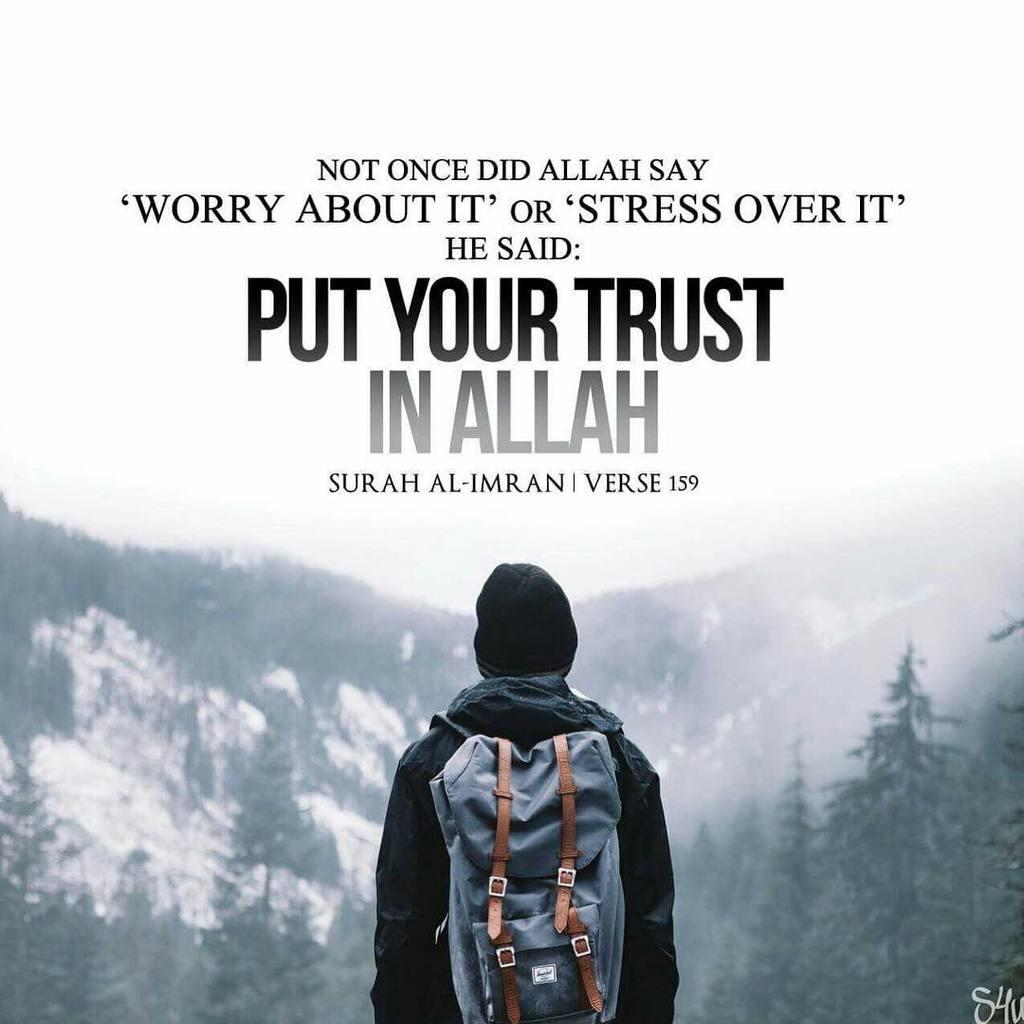Who is present in the image? There is a man in the image. What is the man wearing? The man is wearing a black shirt. What is the man carrying? The man is carrying a backpack. What can be seen in the background of the image? There are trees, snow, and a mountain visible in the background of the image. What books is the man reading in the image? There are no books present in the image; the man is carrying a backpack. 